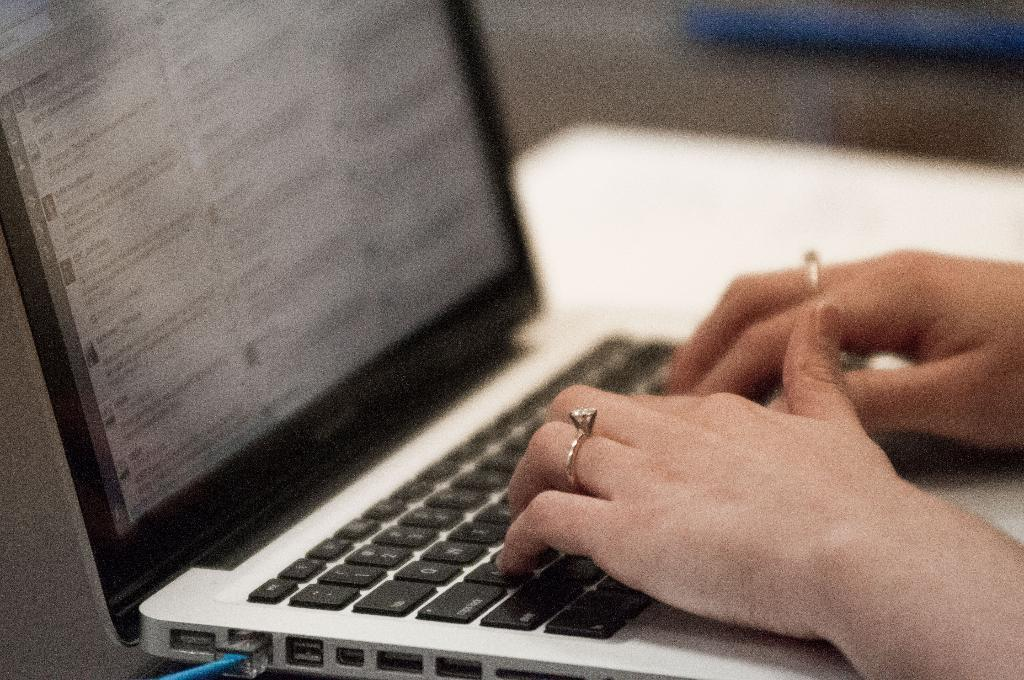Provide a one-sentence caption for the provided image. A laptop computer with several words on it including USDA. 